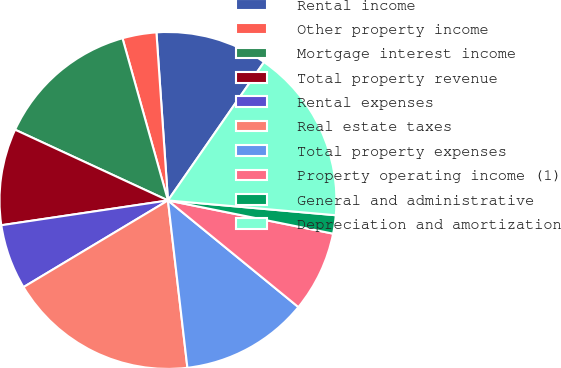<chart> <loc_0><loc_0><loc_500><loc_500><pie_chart><fcel>Rental income<fcel>Other property income<fcel>Mortgage interest income<fcel>Total property revenue<fcel>Rental expenses<fcel>Real estate taxes<fcel>Total property expenses<fcel>Property operating income (1)<fcel>General and administrative<fcel>Depreciation and amortization<nl><fcel>10.75%<fcel>3.26%<fcel>13.75%<fcel>9.25%<fcel>6.25%<fcel>18.24%<fcel>12.25%<fcel>7.75%<fcel>1.76%<fcel>16.74%<nl></chart> 